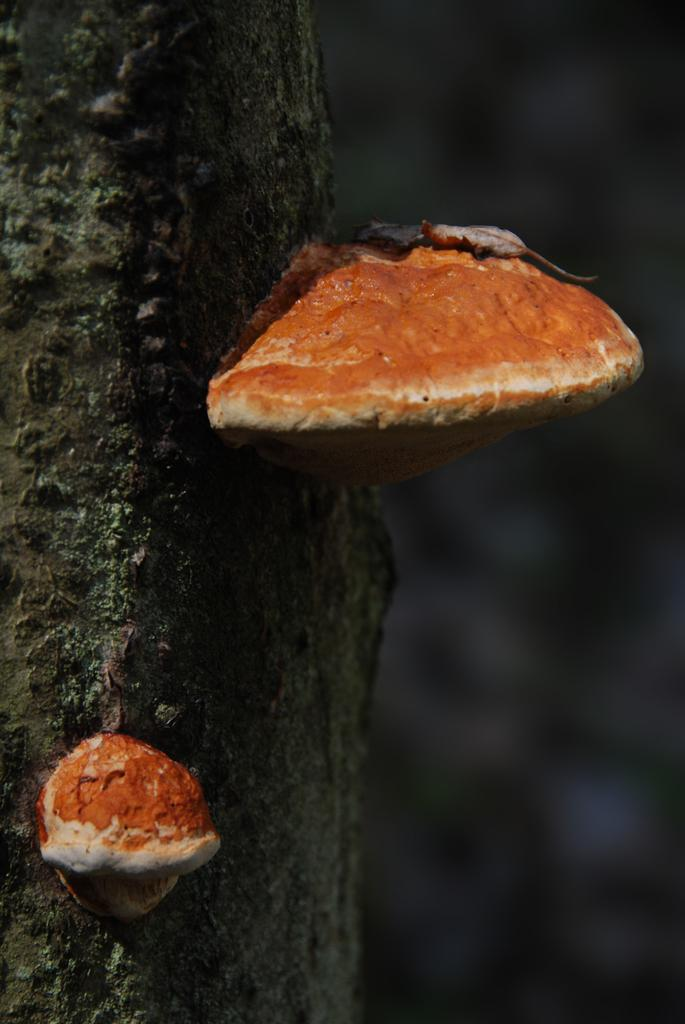What are the two mushroom-like objects in the image attached to? The mushroom-like objects are attached to a tree stump. Can you describe the appearance of one of the mushroom-like objects? One of the mushroom-like objects has a dried leaf on it. How would you describe the overall lighting in the image? The background of the image is dark and blurred. What type of minister is depicted in the image? There is no minister present in the image; it features two mushroom-like objects attached to a tree stump. Can you tell me how many bricks are visible in the image? There are no bricks present in the image. 